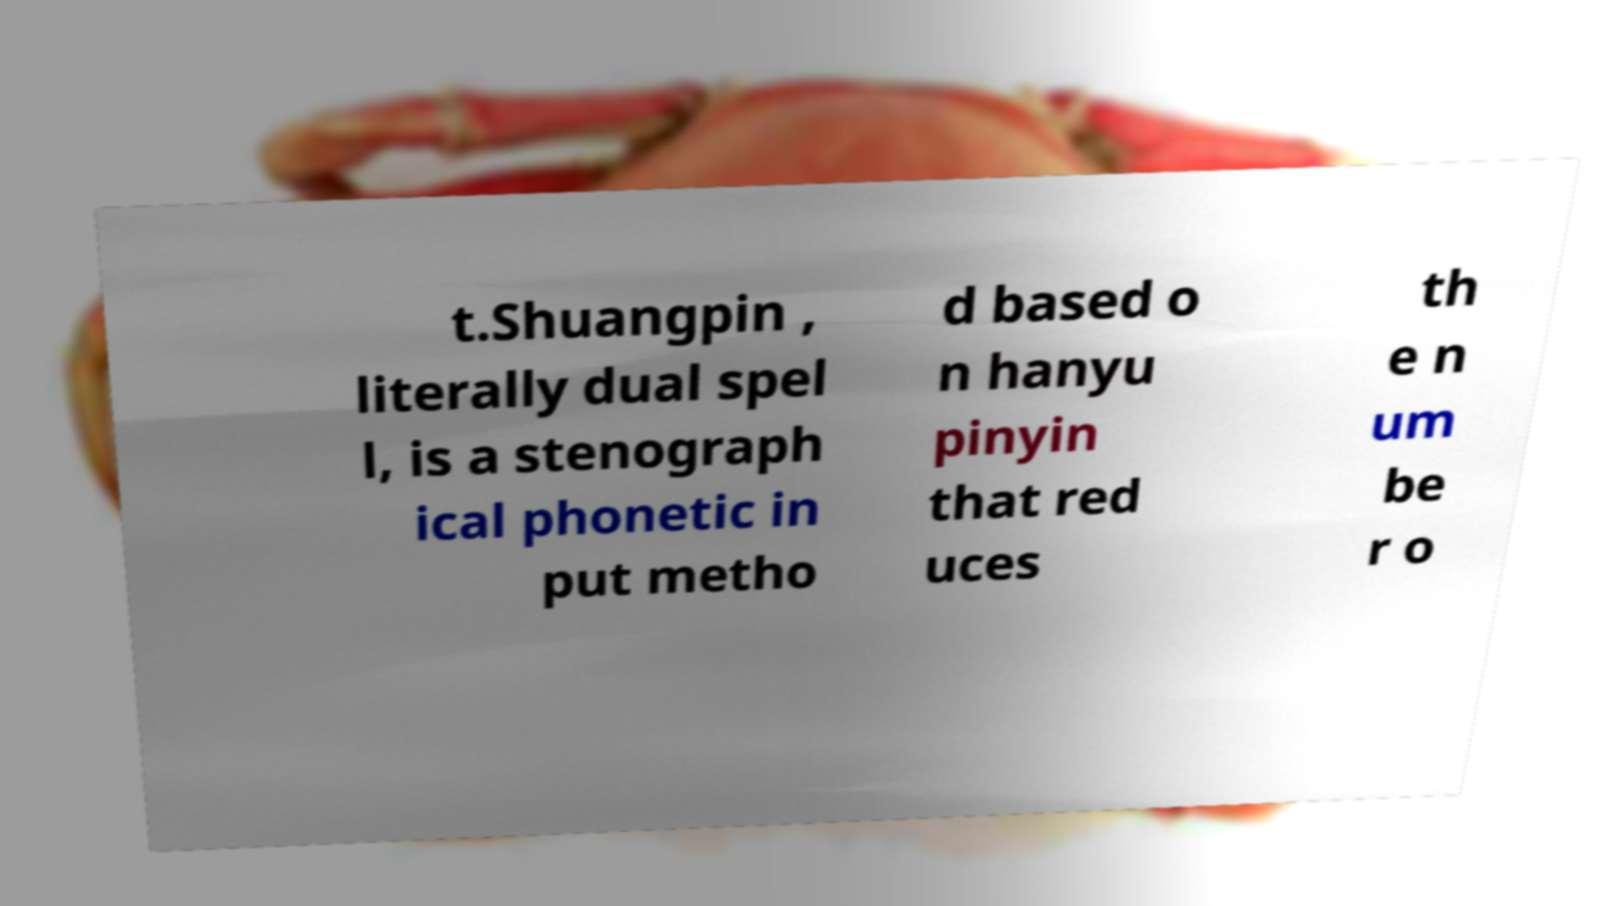Could you extract and type out the text from this image? t.Shuangpin , literally dual spel l, is a stenograph ical phonetic in put metho d based o n hanyu pinyin that red uces th e n um be r o 